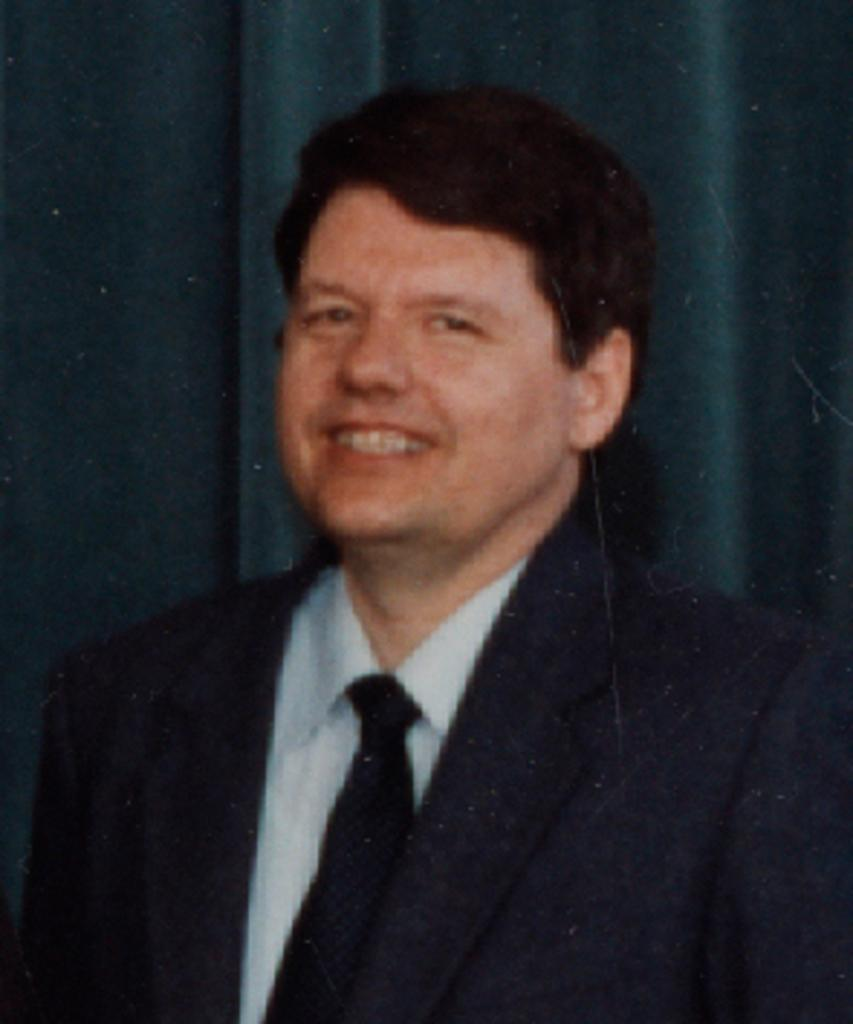What color is the dress that the person in the image is wearing? The person in the image is wearing a black and white dress. What color is the tie that the person is wearing? The person's tie is black. What can be seen in the background of the image? There is a curtain in the background of the image. What type of game is being played in the image? There is no game present in the image; it features a person wearing a black and white dress with a black tie and a curtain in the background. How many legs does the person have in the image? The number of legs cannot be determined from the image, as only the upper body and head are visible. 